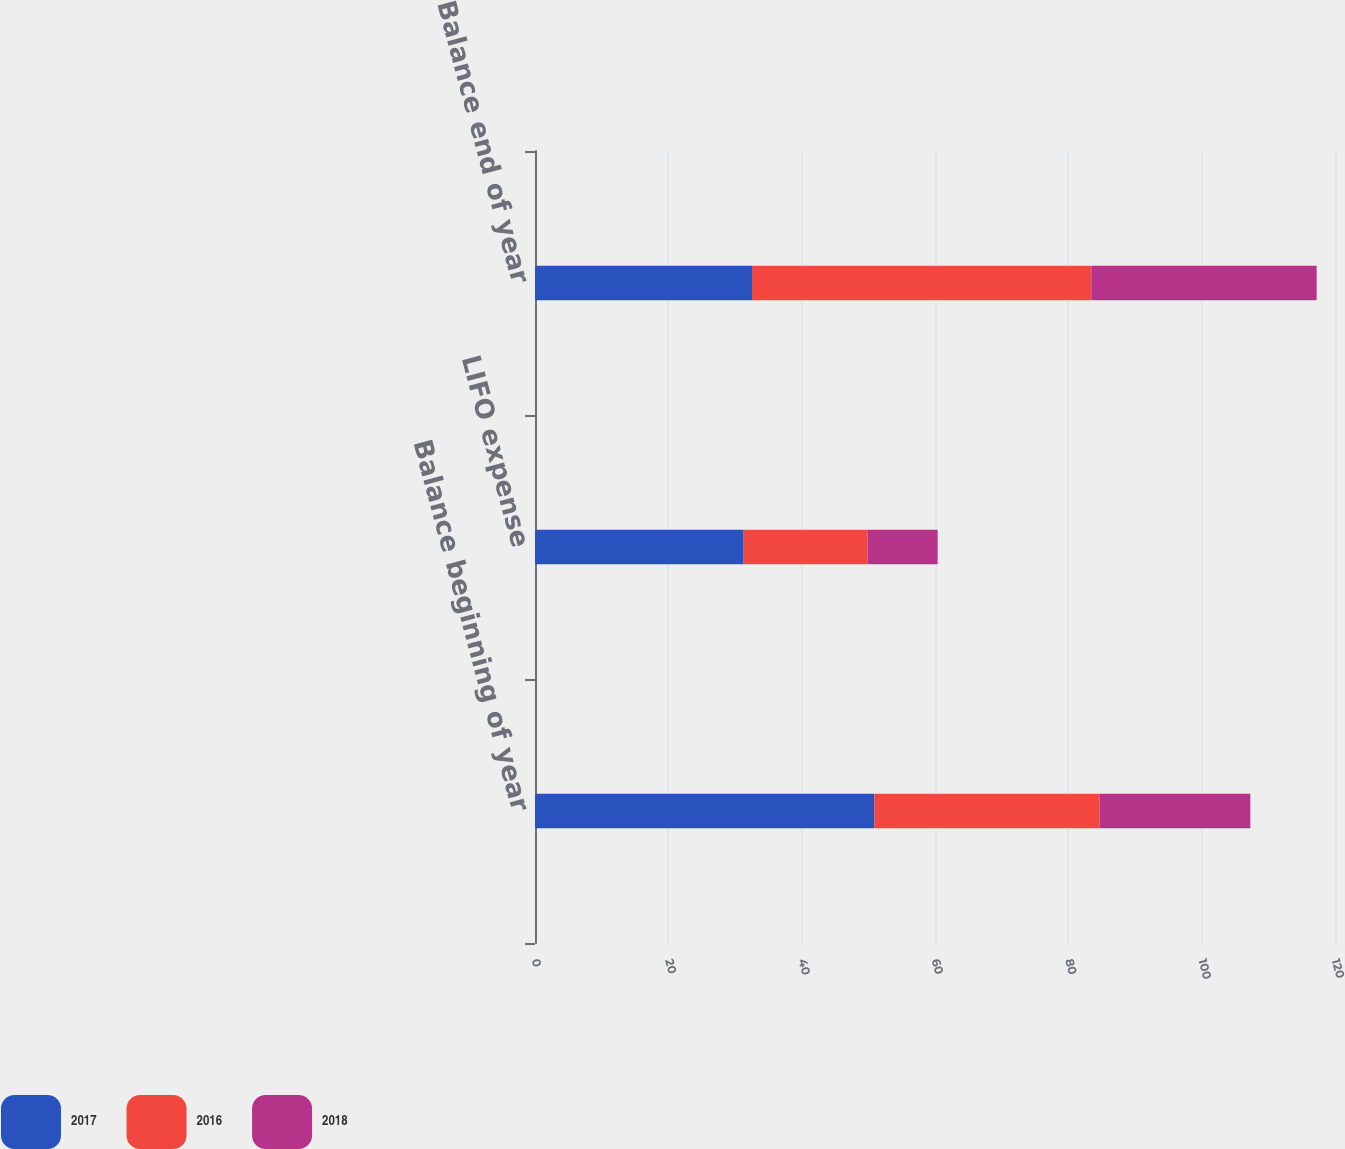Convert chart to OTSL. <chart><loc_0><loc_0><loc_500><loc_500><stacked_bar_chart><ecel><fcel>Balance beginning of year<fcel>LIFO expense<fcel>Balance end of year<nl><fcel>2017<fcel>50.9<fcel>31.3<fcel>32.55<nl><fcel>2016<fcel>33.8<fcel>18.6<fcel>50.9<nl><fcel>2018<fcel>22.6<fcel>10.5<fcel>33.8<nl></chart> 